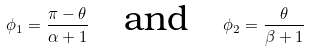Convert formula to latex. <formula><loc_0><loc_0><loc_500><loc_500>\phi _ { 1 } = \frac { \pi - \theta } { \alpha + 1 } \quad \text {and} \quad \phi _ { 2 } = \frac { \theta } { \beta + 1 }</formula> 